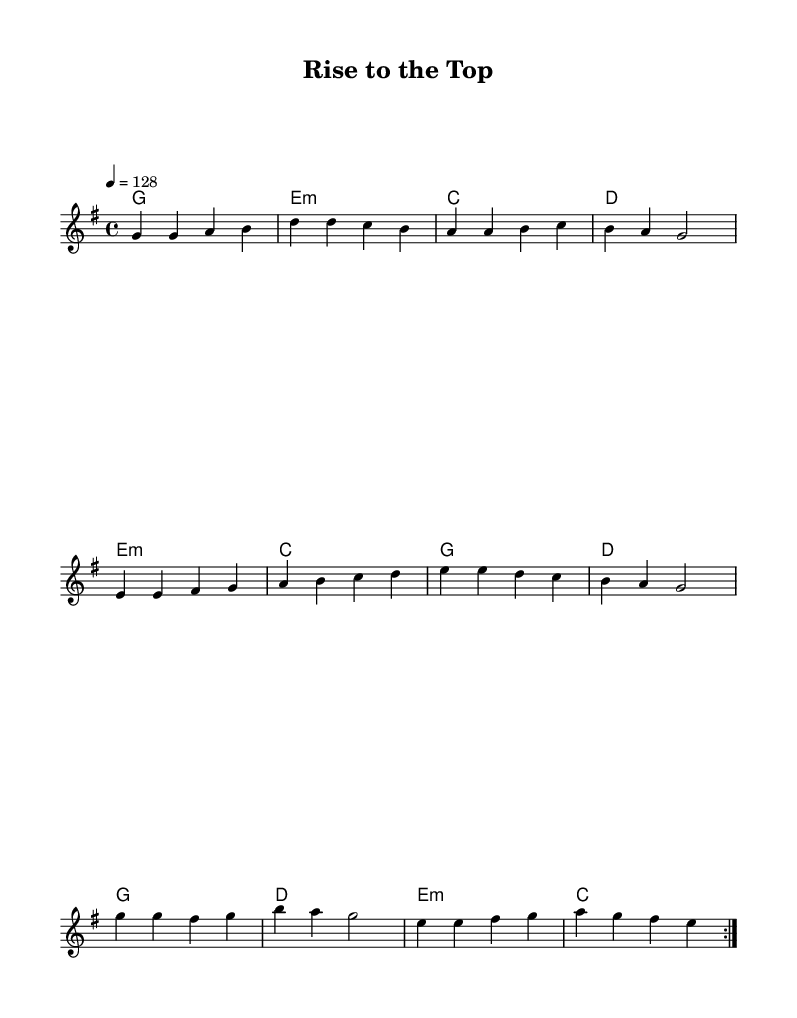What is the key signature of this music? The key signature is G major, which has one sharp (F#). It can be identified from the indicated key signature at the beginning of the score.
Answer: G major What is the time signature of this music? The time signature is 4/4, which means there are four beats in each measure and each quarter note receives one beat. This is indicated by the notation at the beginning of the score.
Answer: 4/4 What is the tempo marking for this piece? The tempo marking is 128 beats per minute, denoted by the tempo indication at the beginning of the score. This means the music should be played at a moderately fast pace.
Answer: 128 How many measures are in the verse section? The verse section consists of 4 measures. This can be counted from the repeated segment that includes specific melody and harmony before moving on to the pre-chorus.
Answer: 4 What chord follows the melody on the first beat of the chorus? The chord that follows the melody on the first beat of the chorus is G major. This is determined by looking at the chord symbols directly above the melody notes in the score.
Answer: G What is the significance of the repeat signs in the music? The repeat signs indicate that the section enclosed should be played twice, allowing for a reinforcement of the musical ideas presented in those measures. In this score, this is applied to both the verse and pre-chorus sections.
Answer: Play twice Which part of the song typically highlights achievements in K-Pop tracks? The chorus highlights achievements, as it often carries the main message of celebration or triumph in K-Pop songs. This is reflected in the structure where important themes are emphasized.
Answer: Chorus 